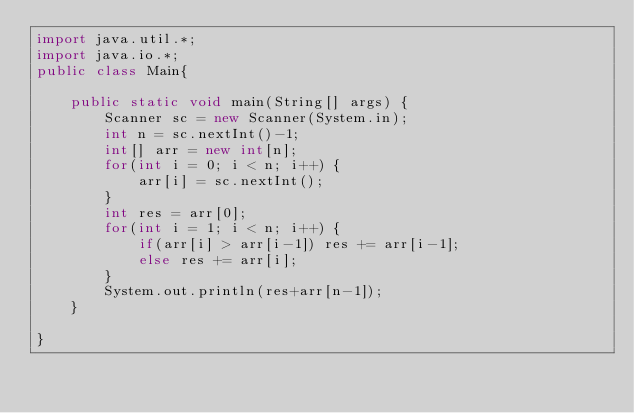Convert code to text. <code><loc_0><loc_0><loc_500><loc_500><_Java_>import java.util.*;
import java.io.*;
public class Main{

	public static void main(String[] args) {
		Scanner sc = new Scanner(System.in);
		int n = sc.nextInt()-1;
		int[] arr = new int[n];
		for(int i = 0; i < n; i++) {
			arr[i] = sc.nextInt();
		}
		int res = arr[0];
		for(int i = 1; i < n; i++) {
			if(arr[i] > arr[i-1]) res += arr[i-1];
			else res += arr[i];
		}
		System.out.println(res+arr[n-1]);
	}

}
</code> 